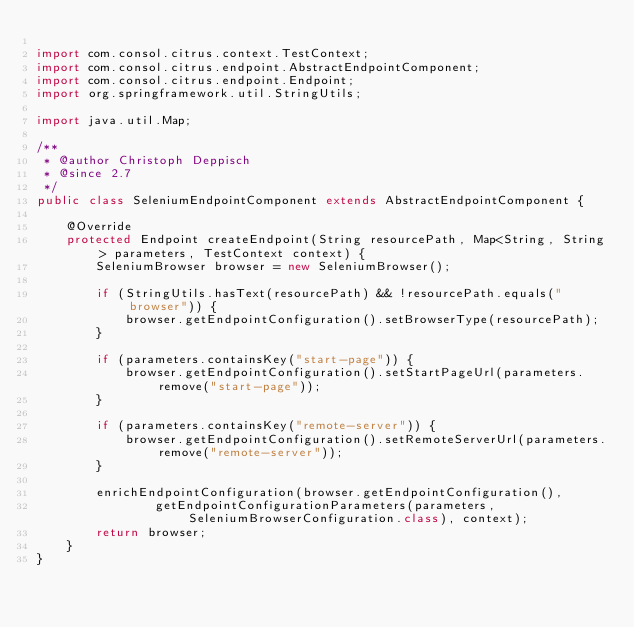<code> <loc_0><loc_0><loc_500><loc_500><_Java_>
import com.consol.citrus.context.TestContext;
import com.consol.citrus.endpoint.AbstractEndpointComponent;
import com.consol.citrus.endpoint.Endpoint;
import org.springframework.util.StringUtils;

import java.util.Map;

/**
 * @author Christoph Deppisch
 * @since 2.7
 */
public class SeleniumEndpointComponent extends AbstractEndpointComponent {

    @Override
    protected Endpoint createEndpoint(String resourcePath, Map<String, String> parameters, TestContext context) {
        SeleniumBrowser browser = new SeleniumBrowser();

        if (StringUtils.hasText(resourcePath) && !resourcePath.equals("browser")) {
            browser.getEndpointConfiguration().setBrowserType(resourcePath);
        }

        if (parameters.containsKey("start-page")) {
            browser.getEndpointConfiguration().setStartPageUrl(parameters.remove("start-page"));
        }

        if (parameters.containsKey("remote-server")) {
            browser.getEndpointConfiguration().setRemoteServerUrl(parameters.remove("remote-server"));
        }

        enrichEndpointConfiguration(browser.getEndpointConfiguration(),
                getEndpointConfigurationParameters(parameters, SeleniumBrowserConfiguration.class), context);
        return browser;
    }
}
</code> 